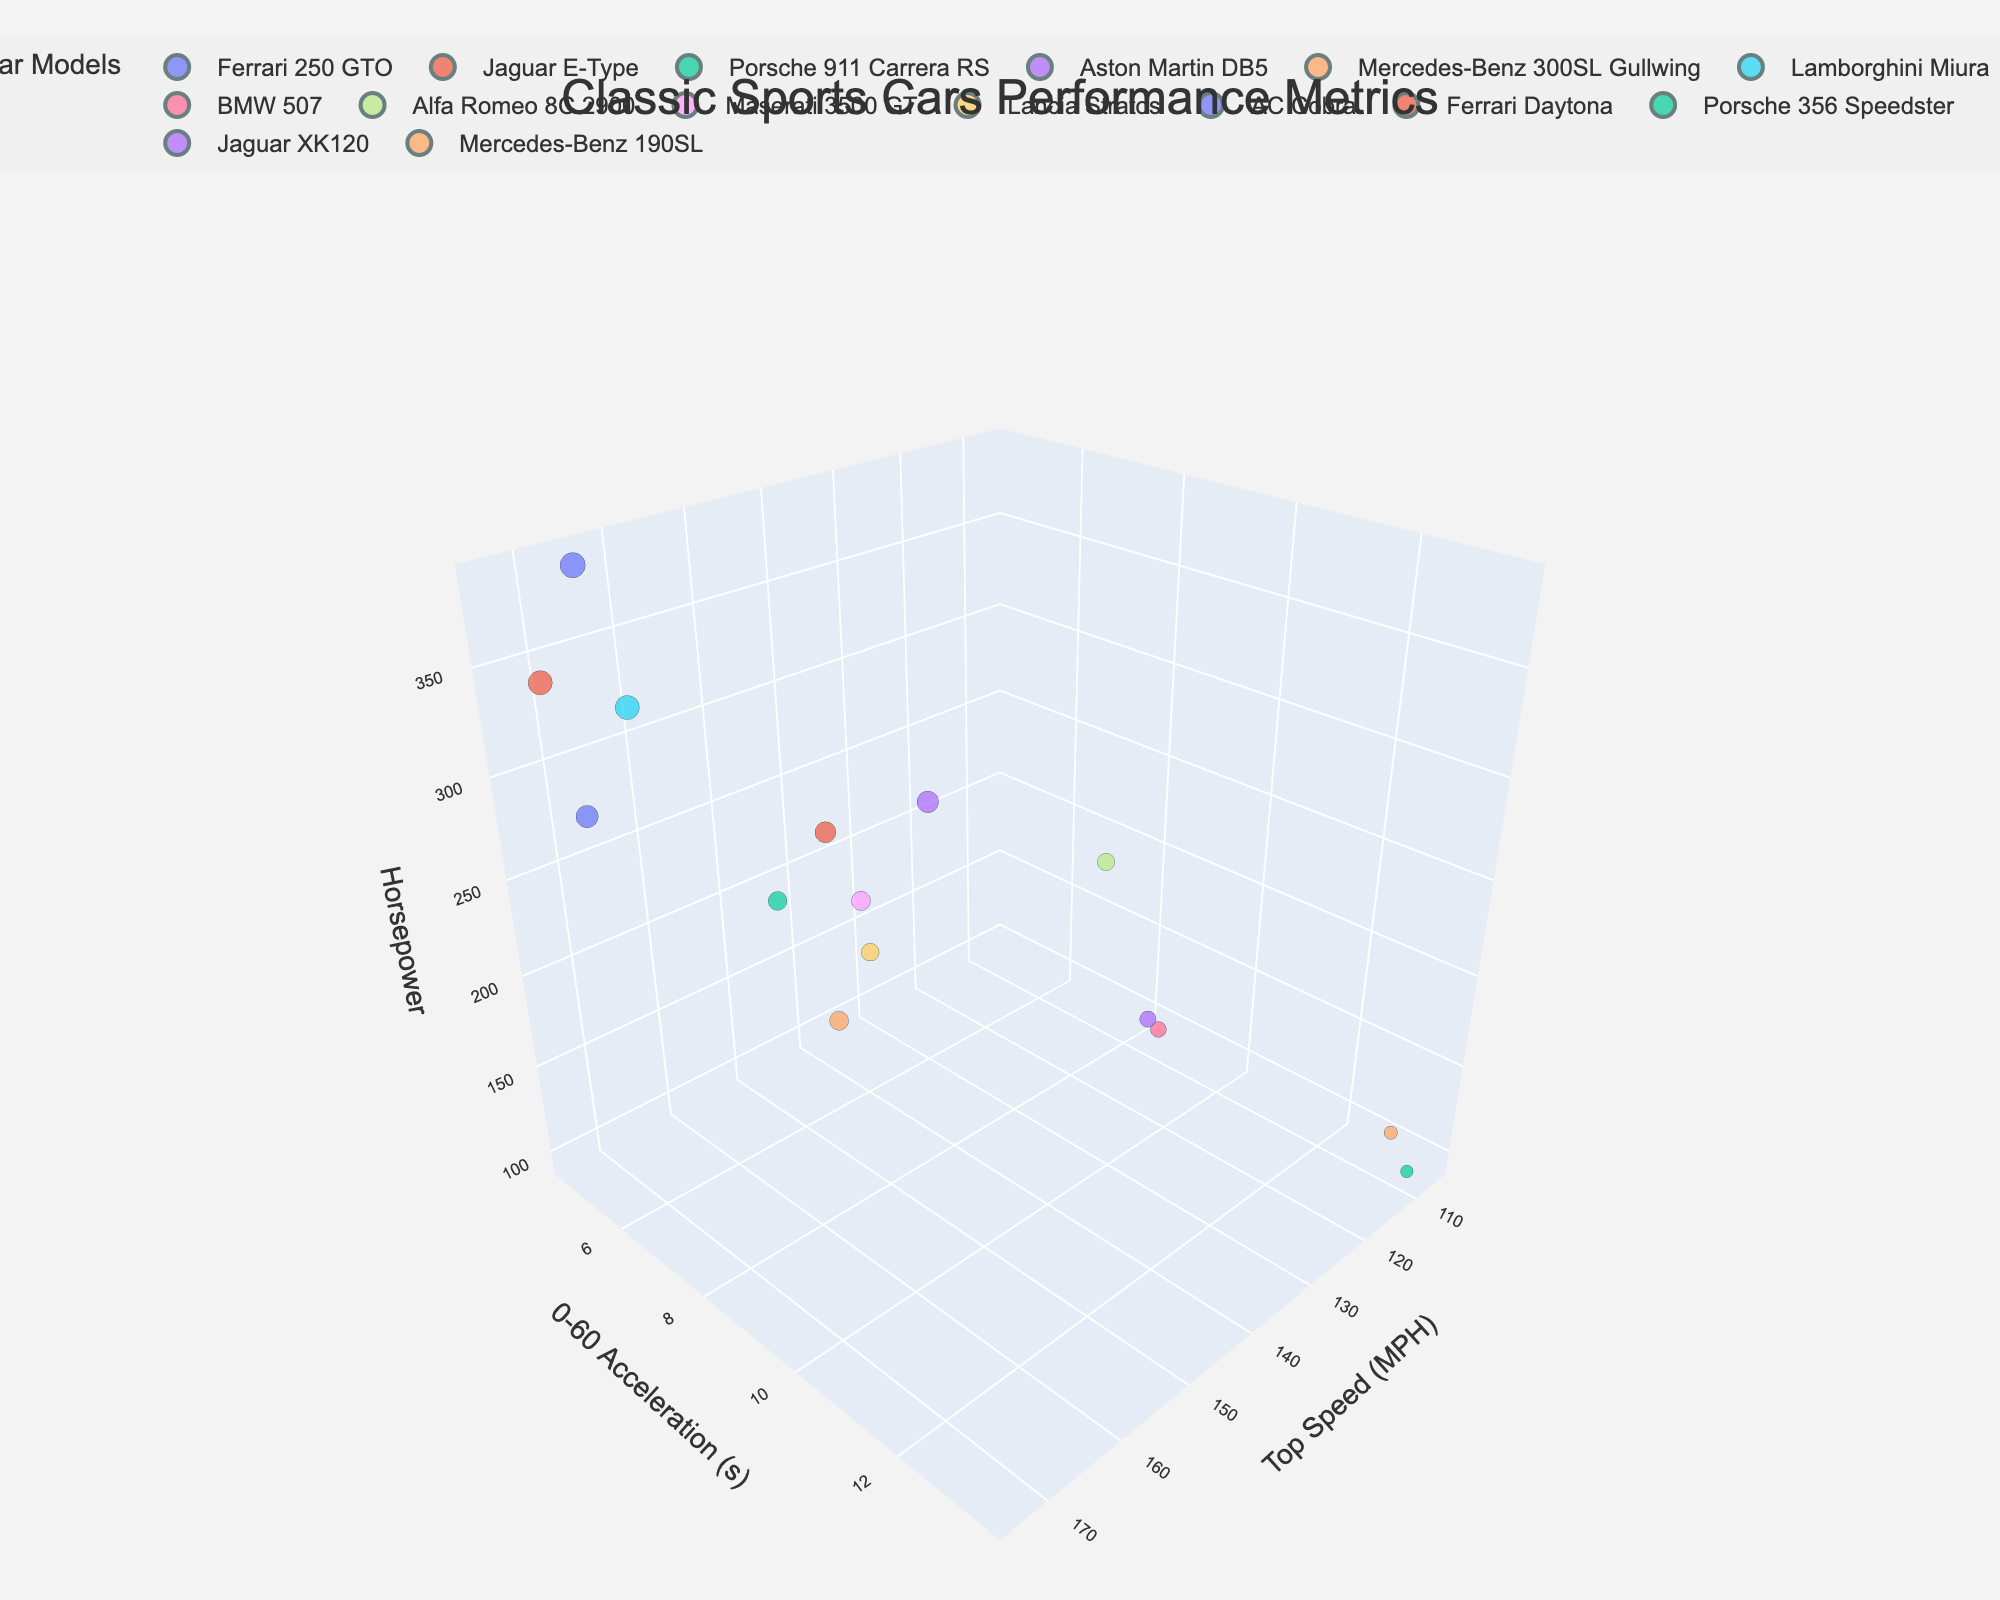what is the title of the plot? The title can be found at the top of the plot. It is typically descriptive of the dataset being visualized. In this case, it states the general topic of the performance metrics of classic sports cars.
Answer: Classic Sports Cars Performance Metrics how many cars have a top speed over 160 mph? To answer this, identify the data points where the x-coordinate (Top Speed in MPH) is greater than 160. Count these points.
Answer: 5 which car has the lowest 0-60 acceleration time? Find the point with the smallest y-coordinate (0-60 Acceleration time) and look at the associated car model.
Answer: AC Cobra what is the average horsepower of the cars with a top speed less than 120 mph? Select the cars with a top speed (x-coordinate) less than 120. Sum their horsepower values (z-coordinate) and divide by the number of such cars.
Answer: (150 + 180 + 95 + 160 + 105) / 5 = 138 which car has the highest combination of top speed and horsepower? To find the car with the maximum sum of x-coordinate (Top Speed) and z-coordinate (Horsepower), sum these values for each car and identify the highest.
Answer: Ferrari Daytona between the Porsche 911 Carrera RS and the Maserati 3500 GT, which has better acceleration? Compare the 0-60 Acceleration times (y-coordinate) of the two models. The lower value indicates better acceleration.
Answer: Porsche 911 Carrera RS what is the range of horsepower among all the cars? Identify the maximum and minimum z-coordinate (Horsepower) values among all data points and find their difference.
Answer: 385 - 95 = 290 which car stands out in terms of higher horsepower but relatively slower acceleration? Look for a car that is high on the z-axis (Horsepower) but further out on the y-axis (0-60 Acceleration time).
Answer: Aston Martin DB5 how many cars are there with a 0-60 acceleration time under 7 seconds? Count the data points where the y-coordinate (0-60 Acceleration time) is less than 7.
Answer: 6 